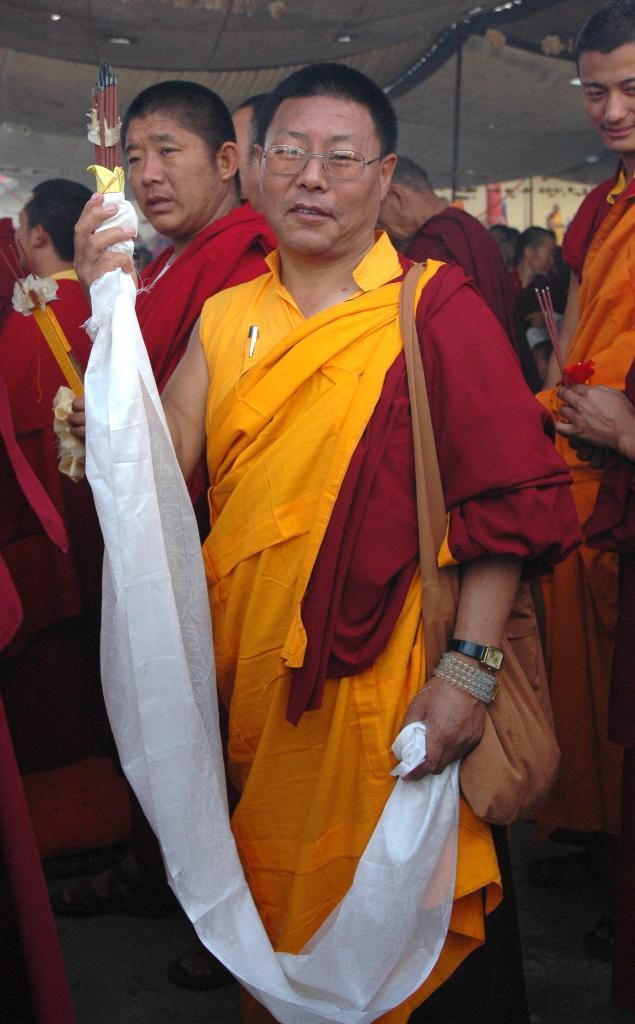What is happening in the image? There are people standing in the image. Can you describe what one person is holding? One person is holding a cloth. What else can you tell us about this person? The person holding the cloth is wearing a handbag. What is another person in the image doing? Another person is holding an object in their hands. What type of blood is visible on the steel object in the image? There is no blood or steel object present in the image. 